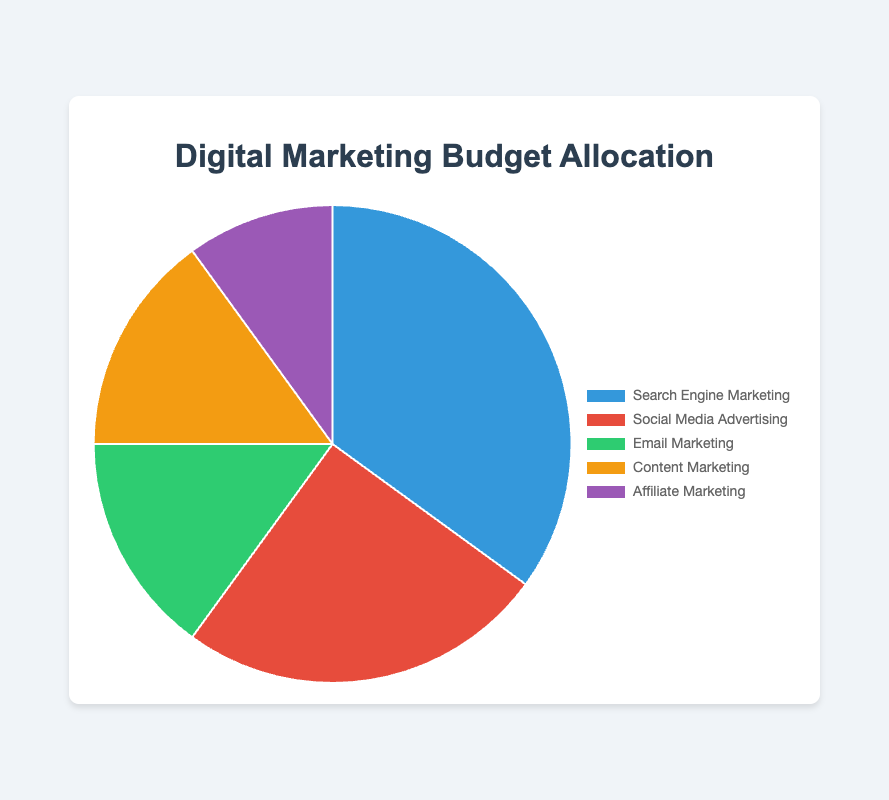What is the allocation percentage for Search Engine Marketing? The chart shows that the color associated with Search Engine Marketing covers 35% of the pie.
Answer: 35% Which digital channel received the second-largest budget allocation? By examining the chart, Social Media Advertising is the second-largest slice, occupying 25% of the pie.
Answer: Social Media Advertising How much more budget is allocated to Email Marketing compared to Affiliate Marketing? Email Marketing is allocated 15% and Affiliate Marketing 10%. The difference is 15% - 10% = 5%.
Answer: 5% What is the total percentage of the budget allocated to Email Marketing and Content Marketing combined? Both Email Marketing and Content Marketing are allocated 15% each. The combined percentage is 15% + 15% = 30%.
Answer: 30% Which digital channel has the smallest allocation percentage and what is it? Affiliate Marketing is the smallest slice on the pie chart, covering 10% of the budget.
Answer: Affiliate Marketing, 10% What is the average budget allocation percentage across all channels? The total budget is 100%, and there are 5 channels. The average is 100% / 5 = 20%.
Answer: 20% Is the budget for Social Media Advertising greater than the combined budget for Email Marketing and Content Marketing? Social Media Advertising has 25%. The combined budget for Email Marketing and Content Marketing is 15% + 15% = 30%. So, 25% < 30%.
Answer: No If an equal amount of budget is transferred from Search Engine Marketing to Email Marketing and Affiliate Marketing, how much would each get? Search Engine Marketing is 35%, Email Marketing is 15%, and Affiliate Marketing is 10%. If 5% is transferred from Search Engine Marketing, they respectively would become 30%, 17.5%, and 12.5%.
Answer: Email Marketing: 17.5%, Affiliate Marketing: 12.5% Which color represents the Content Marketing channel in the chart? Based on the chart, the segment representing Content Marketing should be the fourth color in the list, which is a shade of orange.
Answer: Orange 